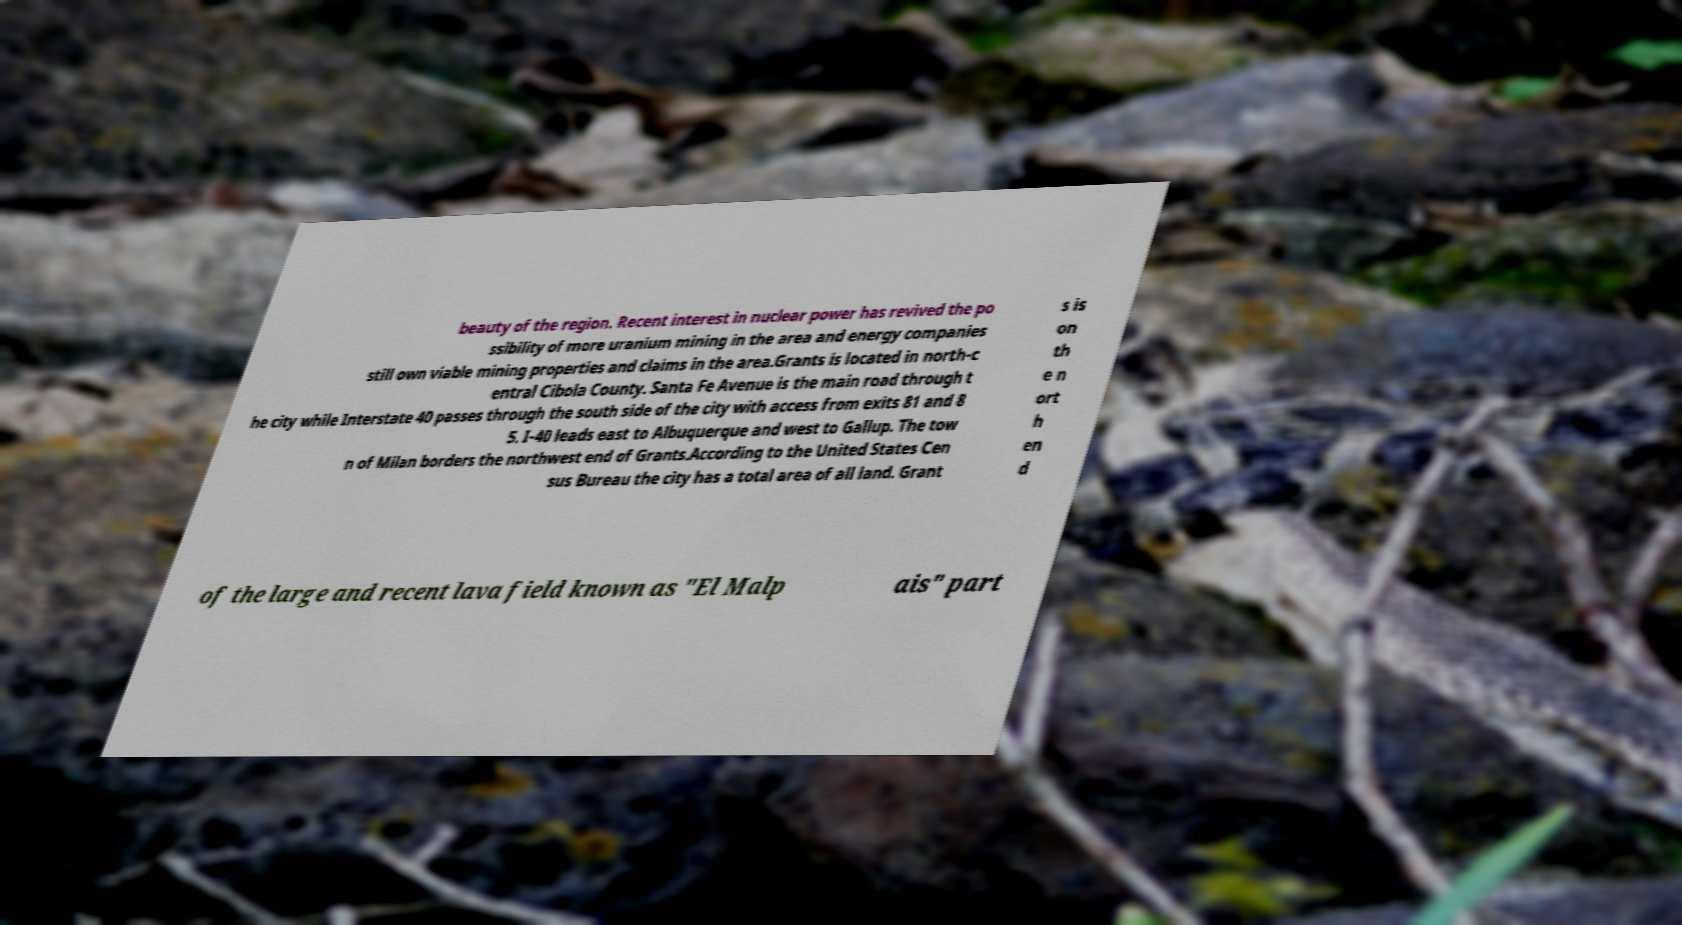I need the written content from this picture converted into text. Can you do that? beauty of the region. Recent interest in nuclear power has revived the po ssibility of more uranium mining in the area and energy companies still own viable mining properties and claims in the area.Grants is located in north-c entral Cibola County. Santa Fe Avenue is the main road through t he city while Interstate 40 passes through the south side of the city with access from exits 81 and 8 5. I-40 leads east to Albuquerque and west to Gallup. The tow n of Milan borders the northwest end of Grants.According to the United States Cen sus Bureau the city has a total area of all land. Grant s is on th e n ort h en d of the large and recent lava field known as "El Malp ais" part 